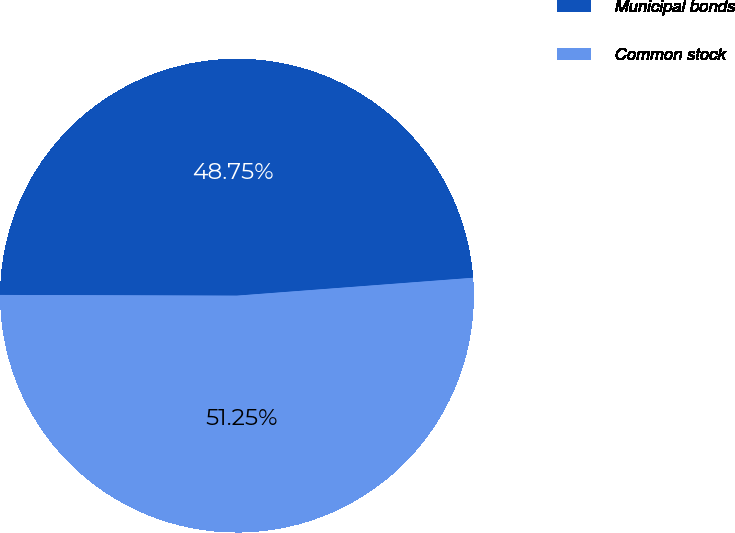<chart> <loc_0><loc_0><loc_500><loc_500><pie_chart><fcel>Municipal bonds<fcel>Common stock<nl><fcel>48.75%<fcel>51.25%<nl></chart> 